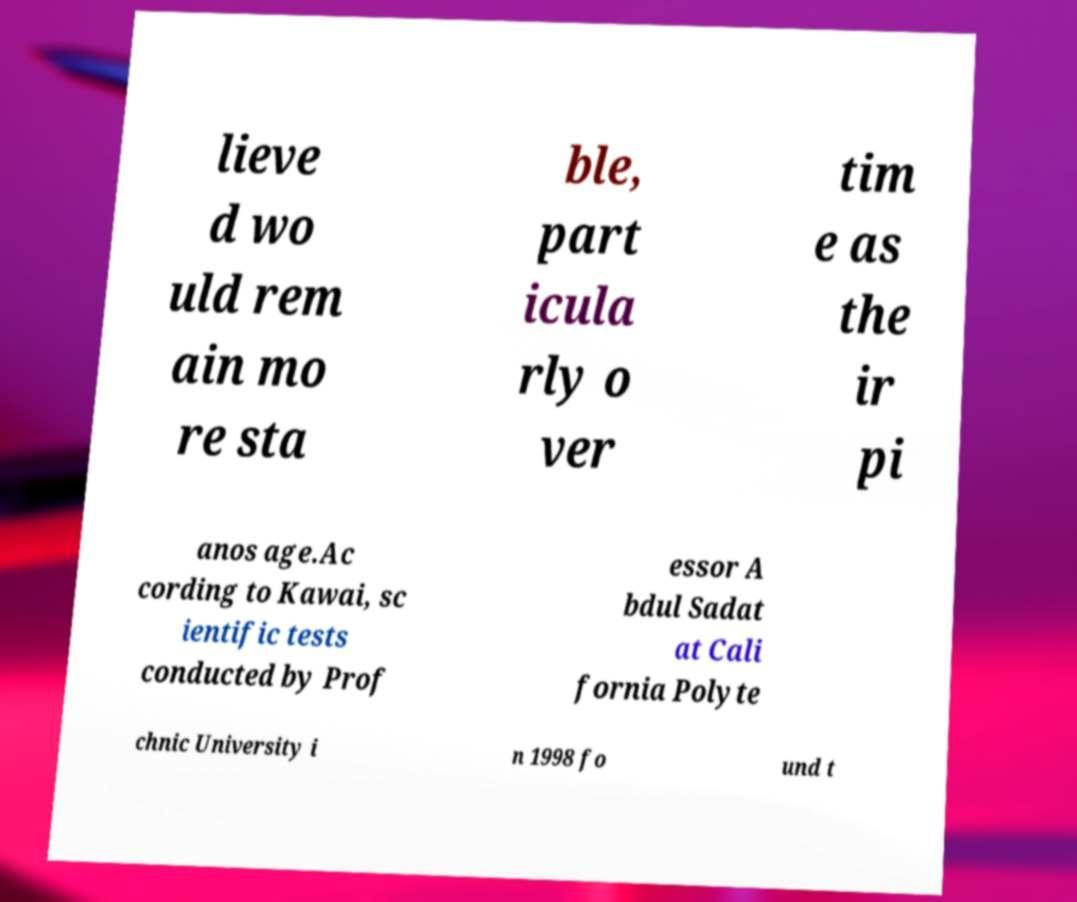There's text embedded in this image that I need extracted. Can you transcribe it verbatim? lieve d wo uld rem ain mo re sta ble, part icula rly o ver tim e as the ir pi anos age.Ac cording to Kawai, sc ientific tests conducted by Prof essor A bdul Sadat at Cali fornia Polyte chnic University i n 1998 fo und t 